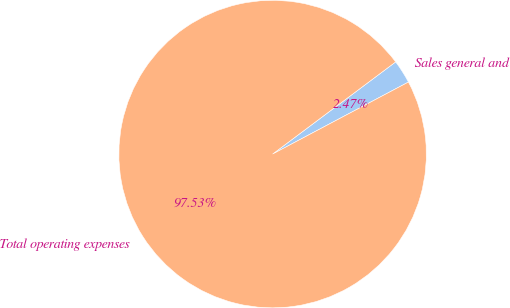Convert chart. <chart><loc_0><loc_0><loc_500><loc_500><pie_chart><fcel>Sales general and<fcel>Total operating expenses<nl><fcel>2.47%<fcel>97.53%<nl></chart> 